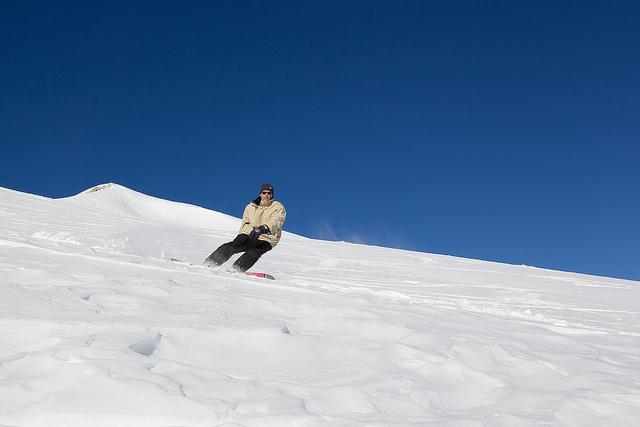What is the temperature there?
Quick response, please. Cold. What sport is the person participating in?
Keep it brief. Snowboarding. Is this man skiing downhill?
Give a very brief answer. Yes. 